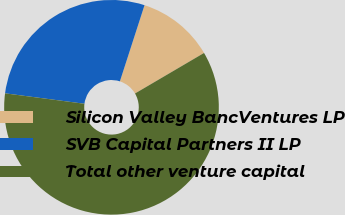Convert chart to OTSL. <chart><loc_0><loc_0><loc_500><loc_500><pie_chart><fcel>Silicon Valley BancVentures LP<fcel>SVB Capital Partners II LP<fcel>Total other venture capital<nl><fcel>11.57%<fcel>27.9%<fcel>60.53%<nl></chart> 